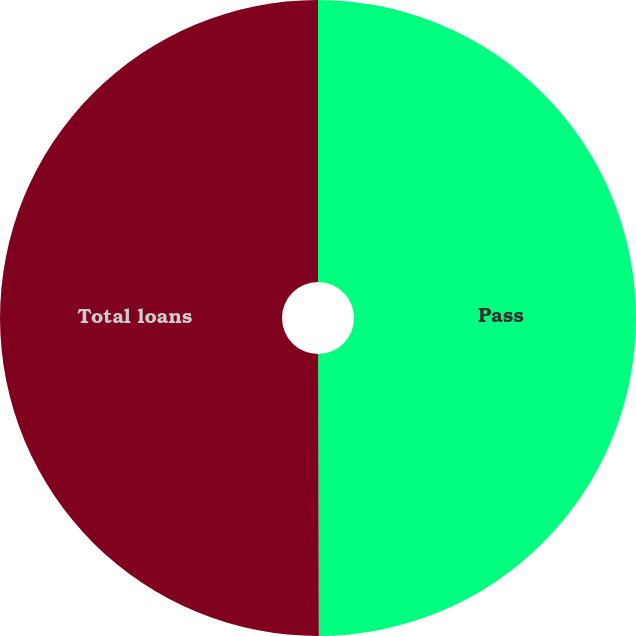Convert chart. <chart><loc_0><loc_0><loc_500><loc_500><pie_chart><fcel>Pass<fcel>Total loans<nl><fcel>49.96%<fcel>50.04%<nl></chart> 